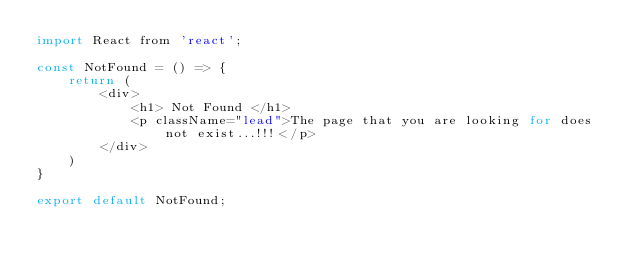Convert code to text. <code><loc_0><loc_0><loc_500><loc_500><_JavaScript_>import React from 'react';

const NotFound = () => {
    return (
        <div>
            <h1> Not Found </h1>
            <p className="lead">The page that you are looking for does not exist...!!!</p>
        </div>
    )
}

export default NotFound;
</code> 